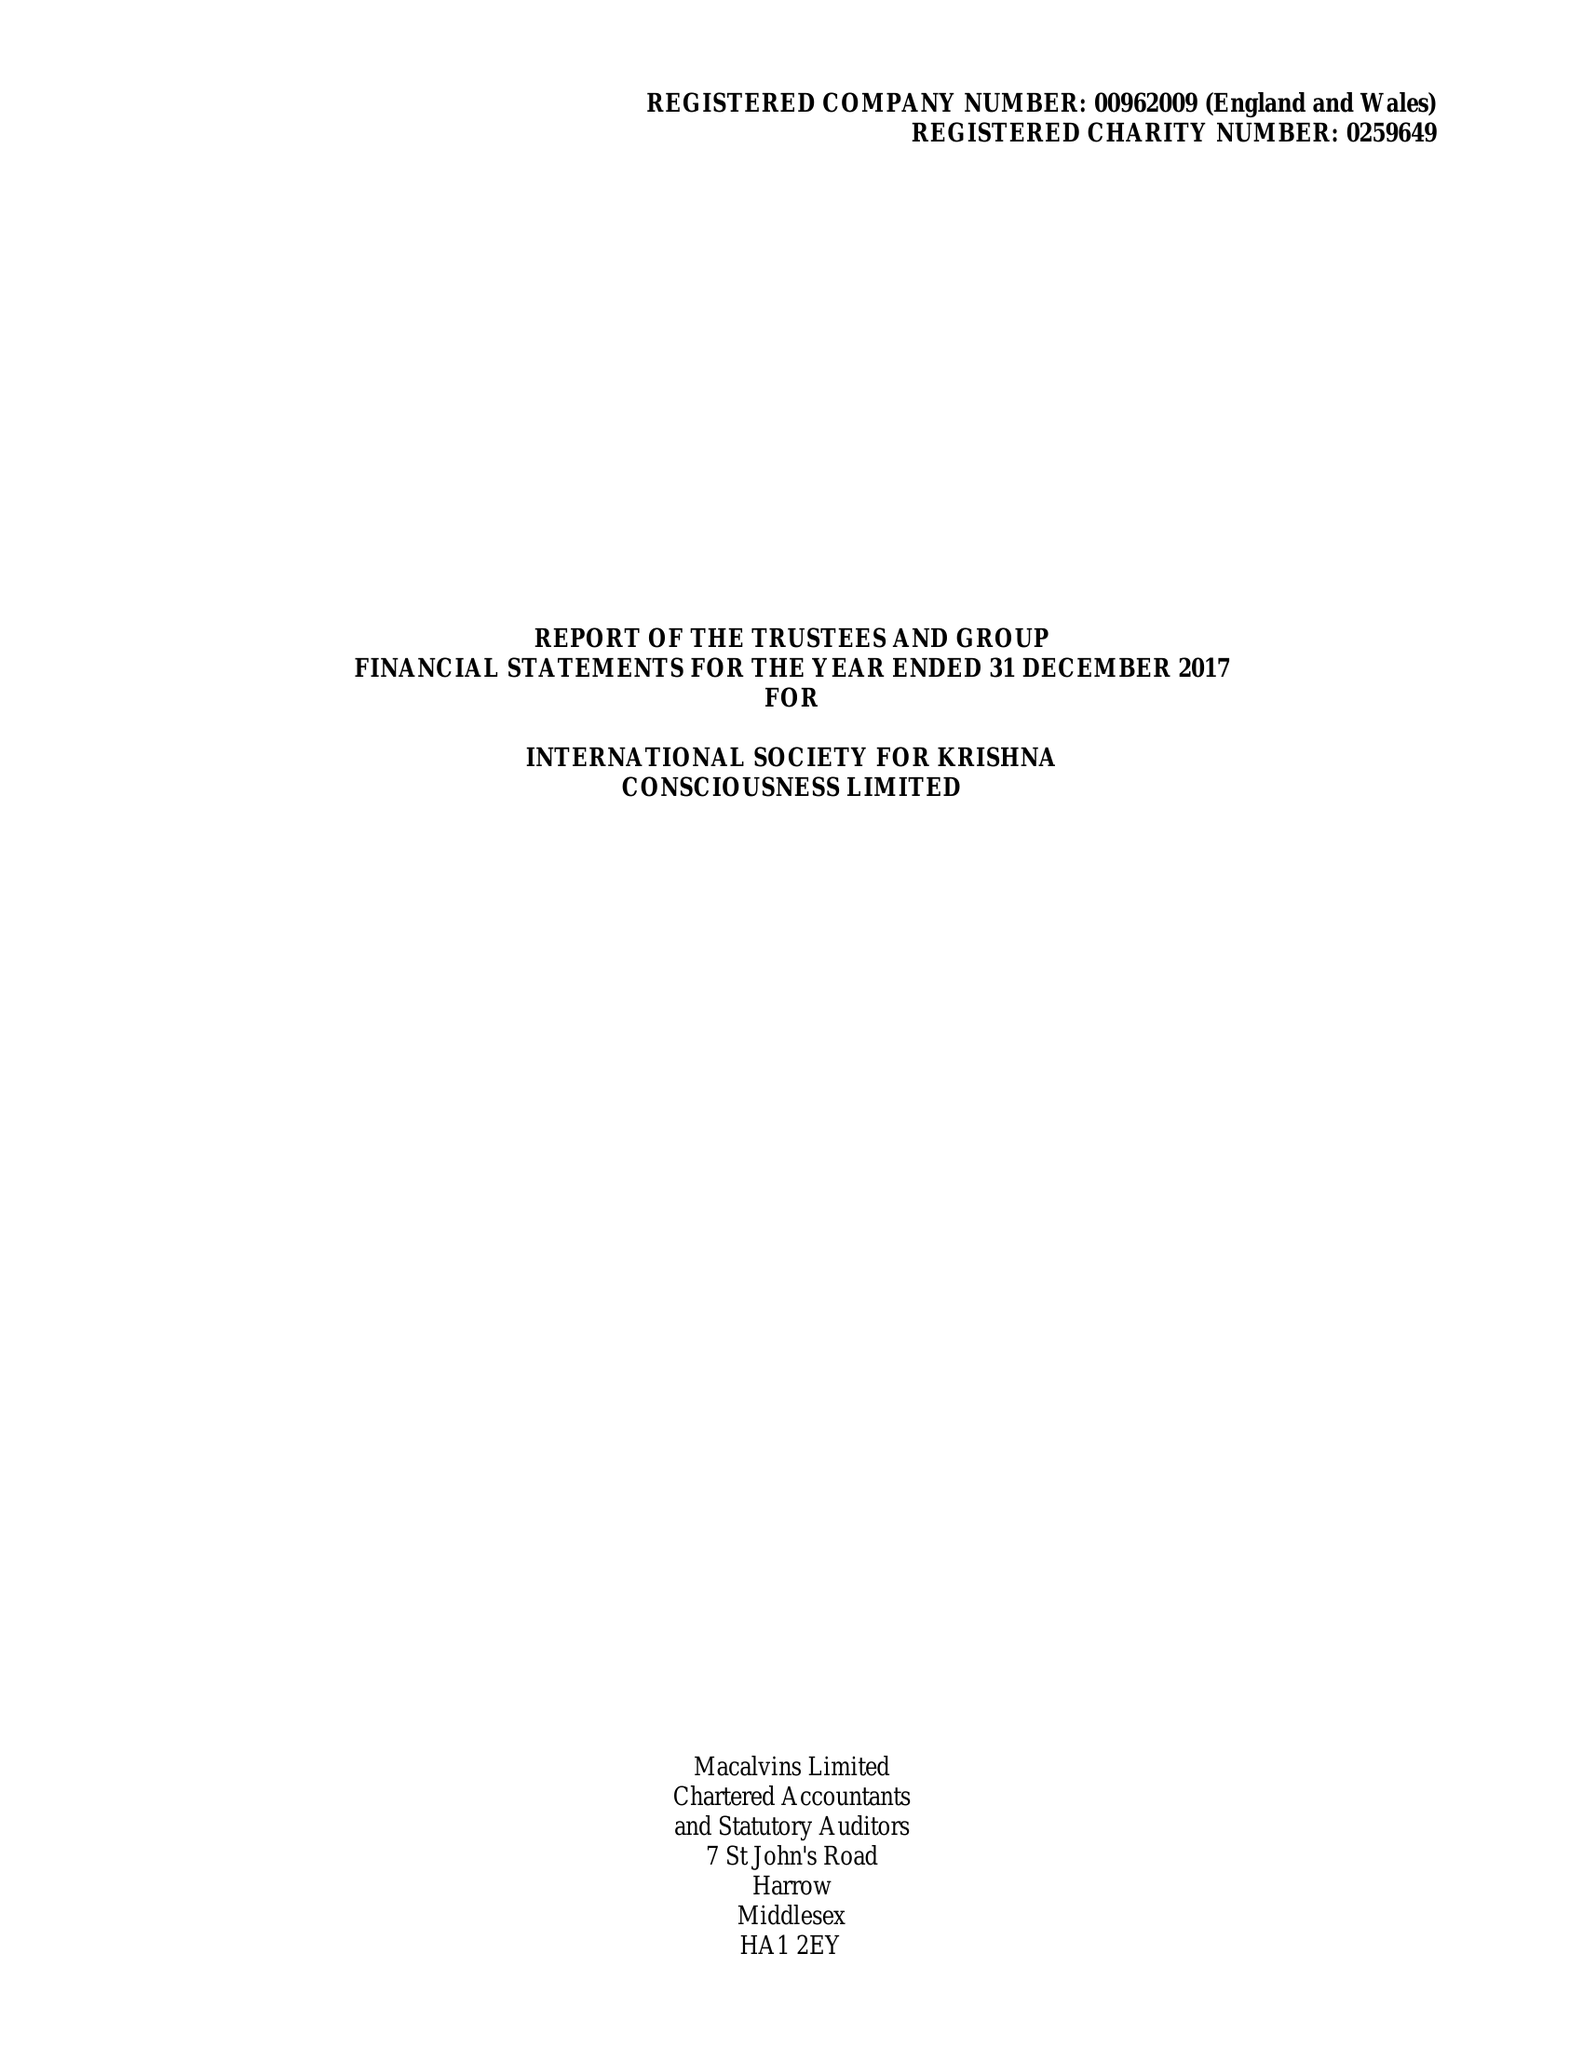What is the value for the address__street_line?
Answer the question using a single word or phrase. 1 WATFORD ROAD 